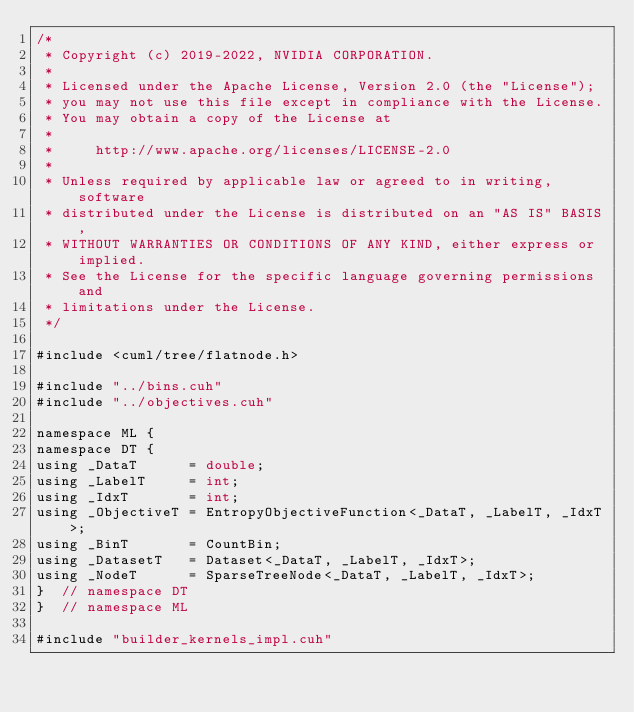Convert code to text. <code><loc_0><loc_0><loc_500><loc_500><_Cuda_>/*
 * Copyright (c) 2019-2022, NVIDIA CORPORATION.
 *
 * Licensed under the Apache License, Version 2.0 (the "License");
 * you may not use this file except in compliance with the License.
 * You may obtain a copy of the License at
 *
 *     http://www.apache.org/licenses/LICENSE-2.0
 *
 * Unless required by applicable law or agreed to in writing, software
 * distributed under the License is distributed on an "AS IS" BASIS,
 * WITHOUT WARRANTIES OR CONDITIONS OF ANY KIND, either express or implied.
 * See the License for the specific language governing permissions and
 * limitations under the License.
 */

#include <cuml/tree/flatnode.h>

#include "../bins.cuh"
#include "../objectives.cuh"

namespace ML {
namespace DT {
using _DataT      = double;
using _LabelT     = int;
using _IdxT       = int;
using _ObjectiveT = EntropyObjectiveFunction<_DataT, _LabelT, _IdxT>;
using _BinT       = CountBin;
using _DatasetT   = Dataset<_DataT, _LabelT, _IdxT>;
using _NodeT      = SparseTreeNode<_DataT, _LabelT, _IdxT>;
}  // namespace DT
}  // namespace ML

#include "builder_kernels_impl.cuh"
</code> 